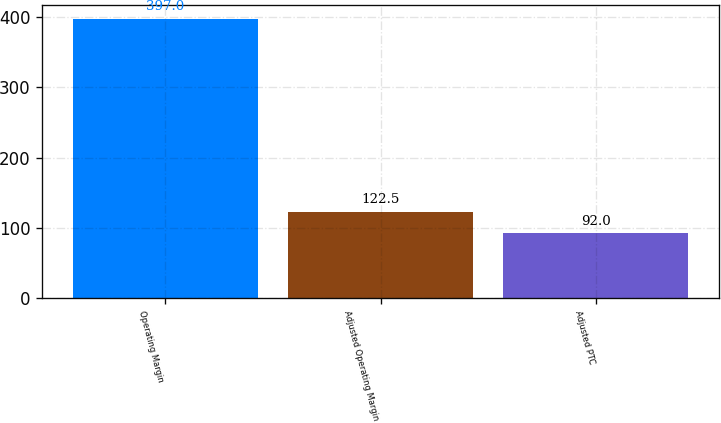<chart> <loc_0><loc_0><loc_500><loc_500><bar_chart><fcel>Operating Margin<fcel>Adjusted Operating Margin<fcel>Adjusted PTC<nl><fcel>397<fcel>122.5<fcel>92<nl></chart> 